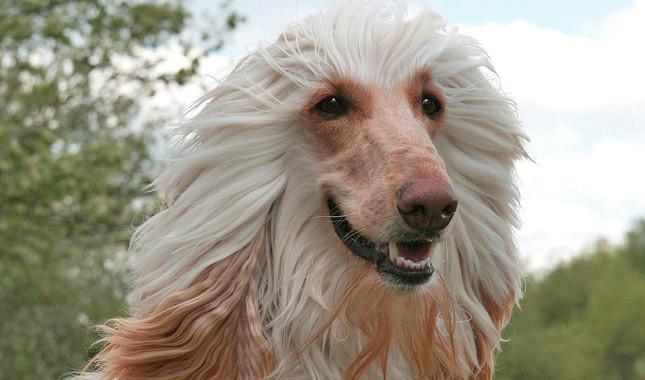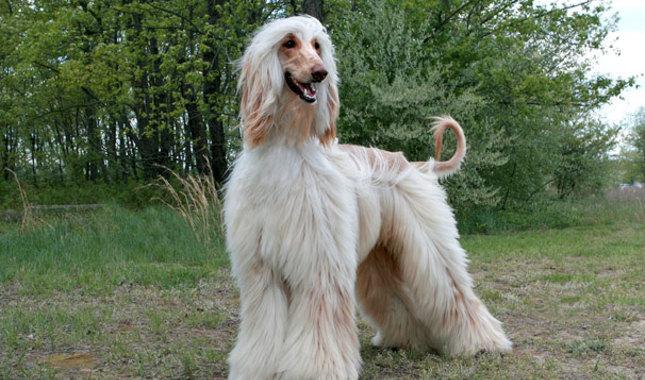The first image is the image on the left, the second image is the image on the right. Considering the images on both sides, is "At least one of the dogs is standing, and you can see a full body shot of the standing dog." valid? Answer yes or no. Yes. The first image is the image on the left, the second image is the image on the right. Considering the images on both sides, is "There is a dog's face in the left image with greenery behind it." valid? Answer yes or no. Yes. The first image is the image on the left, the second image is the image on the right. Examine the images to the left and right. Is the description "In at least one image, there is a single dog with brown tipped ears and small curled tail, facing left with its feet on grass." accurate? Answer yes or no. Yes. 